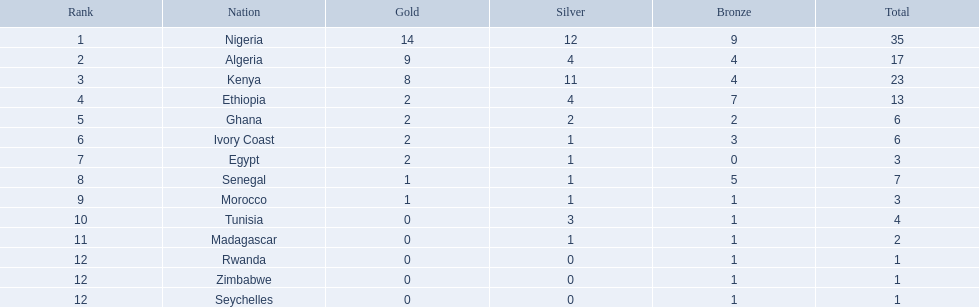Which countries participated in the 1989 african championships in athletics? Nigeria, Algeria, Kenya, Ethiopia, Ghana, Ivory Coast, Egypt, Senegal, Morocco, Tunisia, Madagascar, Rwanda, Zimbabwe, Seychelles. Which countries obtained bronze medals? Nigeria, Algeria, Kenya, Ethiopia, Ghana, Ivory Coast, Senegal, Morocco, Tunisia, Madagascar, Rwanda, Zimbabwe, Seychelles. Which country failed to secure a bronze medal? Egypt. Would you be able to parse every entry in this table? {'header': ['Rank', 'Nation', 'Gold', 'Silver', 'Bronze', 'Total'], 'rows': [['1', 'Nigeria', '14', '12', '9', '35'], ['2', 'Algeria', '9', '4', '4', '17'], ['3', 'Kenya', '8', '11', '4', '23'], ['4', 'Ethiopia', '2', '4', '7', '13'], ['5', 'Ghana', '2', '2', '2', '6'], ['6', 'Ivory Coast', '2', '1', '3', '6'], ['7', 'Egypt', '2', '1', '0', '3'], ['8', 'Senegal', '1', '1', '5', '7'], ['9', 'Morocco', '1', '1', '1', '3'], ['10', 'Tunisia', '0', '3', '1', '4'], ['11', 'Madagascar', '0', '1', '1', '2'], ['12', 'Rwanda', '0', '0', '1', '1'], ['12', 'Zimbabwe', '0', '0', '1', '1'], ['12', 'Seychelles', '0', '0', '1', '1']]} 